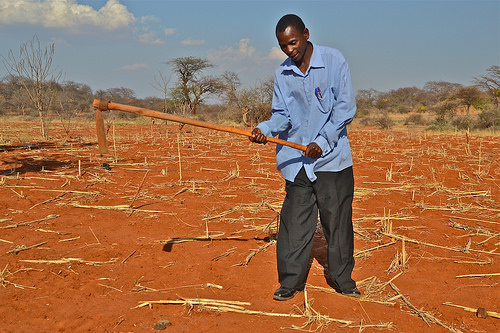<image>
Is the man on the sky? No. The man is not positioned on the sky. They may be near each other, but the man is not supported by or resting on top of the sky. Is there a pant leg next to the tree? No. The pant leg is not positioned next to the tree. They are located in different areas of the scene. 